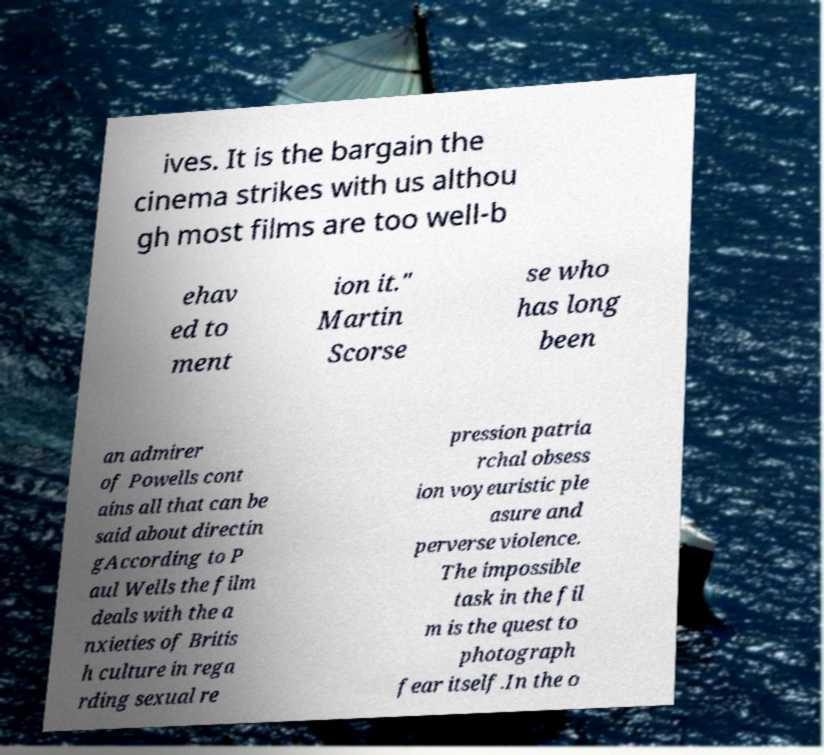For documentation purposes, I need the text within this image transcribed. Could you provide that? ives. It is the bargain the cinema strikes with us althou gh most films are too well-b ehav ed to ment ion it." Martin Scorse se who has long been an admirer of Powells cont ains all that can be said about directin gAccording to P aul Wells the film deals with the a nxieties of Britis h culture in rega rding sexual re pression patria rchal obsess ion voyeuristic ple asure and perverse violence. The impossible task in the fil m is the quest to photograph fear itself.In the o 